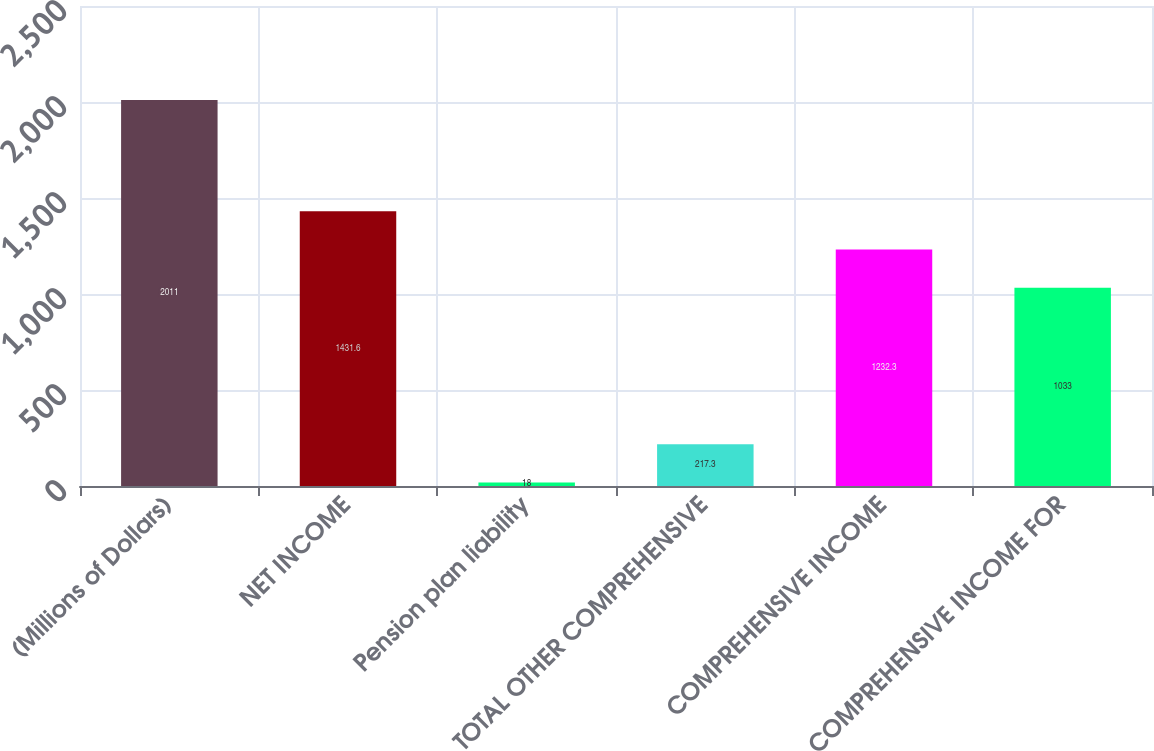Convert chart to OTSL. <chart><loc_0><loc_0><loc_500><loc_500><bar_chart><fcel>(Millions of Dollars)<fcel>NET INCOME<fcel>Pension plan liability<fcel>TOTAL OTHER COMPREHENSIVE<fcel>COMPREHENSIVE INCOME<fcel>COMPREHENSIVE INCOME FOR<nl><fcel>2011<fcel>1431.6<fcel>18<fcel>217.3<fcel>1232.3<fcel>1033<nl></chart> 